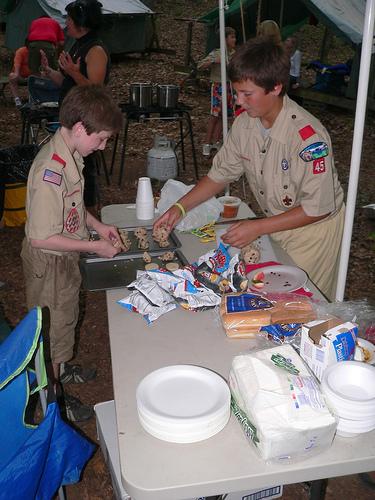How many scouts are baking cookies?
Short answer required. 2. What are they eating?
Short answer required. Cookies. What organization are these members of?
Concise answer only. Boy scouts. 